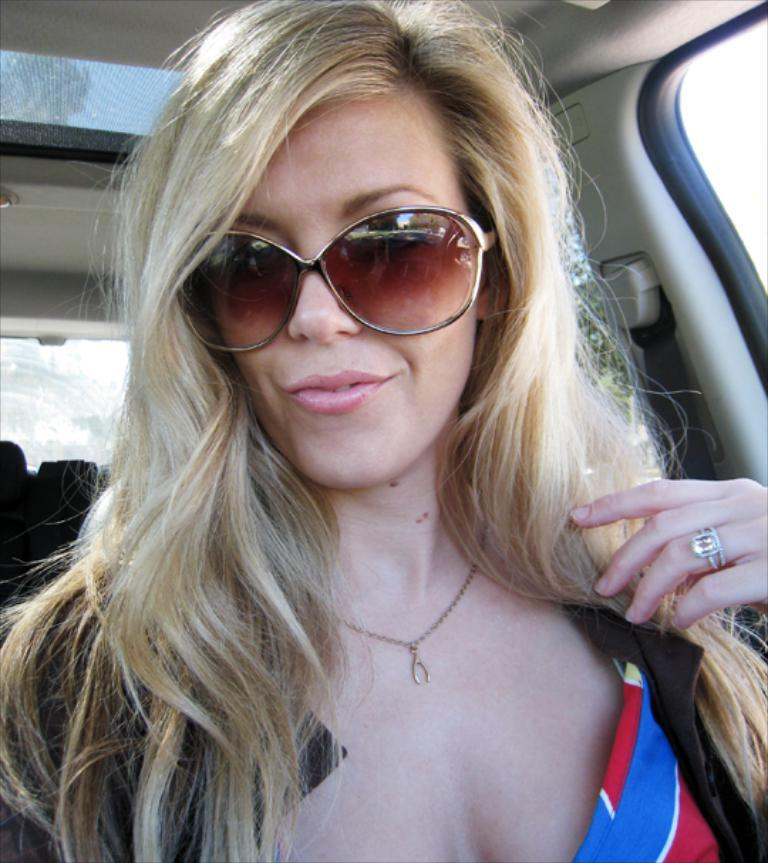Who is present in the image? There is a woman in the image. What is the woman wearing on her face? The woman is wearing goggles. What is the woman doing in the image? The woman is sitting in a car. What type of servant can be seen attending to the woman in the image? There is no servant present in the image; it only shows a woman wearing goggles and sitting in a car. 